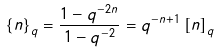<formula> <loc_0><loc_0><loc_500><loc_500>\left \{ n \right \} _ { q } = \frac { 1 - q ^ { - 2 n } } { 1 - q ^ { - 2 } } = q ^ { - n + 1 } \left [ n \right ] _ { q }</formula> 